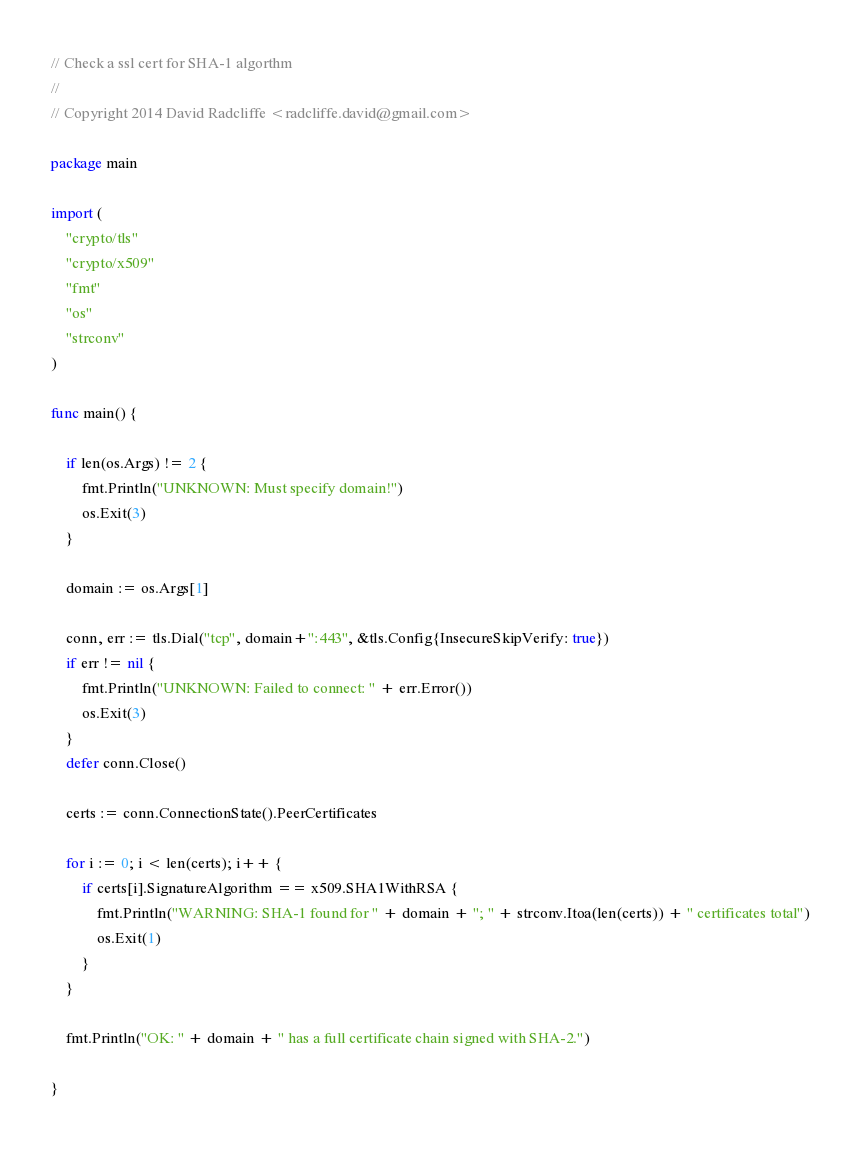<code> <loc_0><loc_0><loc_500><loc_500><_Go_>// Check a ssl cert for SHA-1 algorthm
//
// Copyright 2014 David Radcliffe <radcliffe.david@gmail.com>

package main

import (
	"crypto/tls"
	"crypto/x509"
	"fmt"
	"os"
	"strconv"
)

func main() {

	if len(os.Args) != 2 {
		fmt.Println("UNKNOWN: Must specify domain!")
		os.Exit(3)
	}

	domain := os.Args[1]

	conn, err := tls.Dial("tcp", domain+":443", &tls.Config{InsecureSkipVerify: true})
	if err != nil {
		fmt.Println("UNKNOWN: Failed to connect: " + err.Error())
		os.Exit(3)
	}
	defer conn.Close()

	certs := conn.ConnectionState().PeerCertificates

	for i := 0; i < len(certs); i++ {
		if certs[i].SignatureAlgorithm == x509.SHA1WithRSA {
			fmt.Println("WARNING: SHA-1 found for " + domain + "; " + strconv.Itoa(len(certs)) + " certificates total")
			os.Exit(1)
		}
	}

	fmt.Println("OK: " + domain + " has a full certificate chain signed with SHA-2.")

}
</code> 